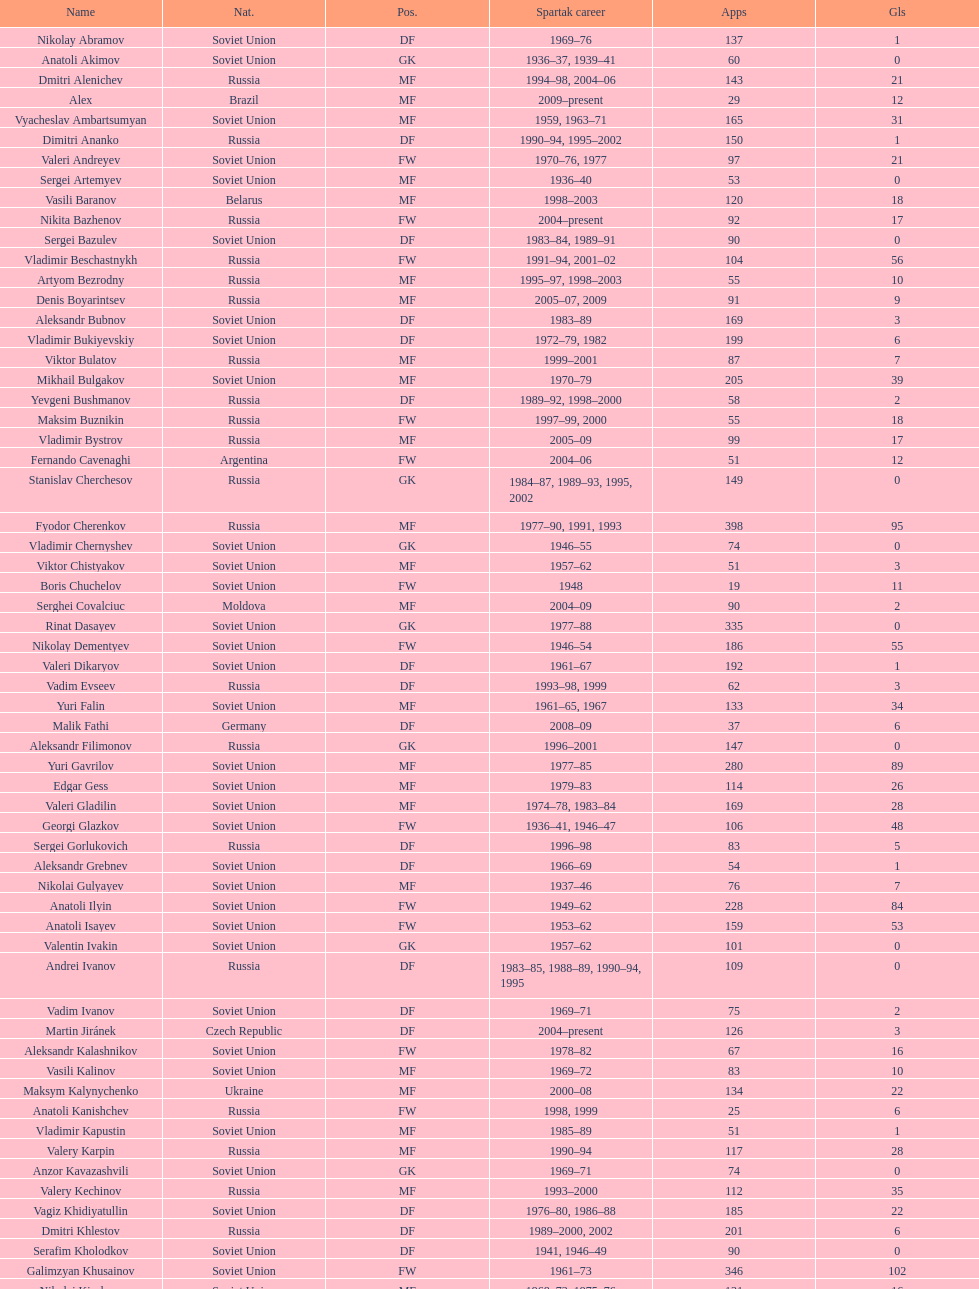Which player has the most appearances with the club? Fyodor Cherenkov. 